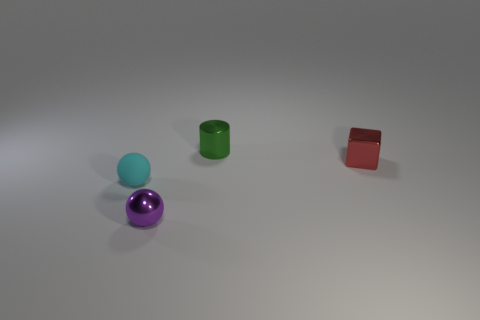How many cylinders are purple objects or cyan things?
Make the answer very short. 0. Is the shape of the tiny rubber thing the same as the tiny green metal object?
Provide a short and direct response. No. There is a object that is behind the tiny red metal object; what size is it?
Your response must be concise. Small. Are there any metal objects of the same color as the small matte ball?
Keep it short and to the point. No. There is a sphere that is to the right of the cyan rubber thing; does it have the same size as the small metal cylinder?
Your answer should be compact. Yes. The small cube is what color?
Your answer should be compact. Red. There is a small thing that is right of the object behind the shiny cube; what is its color?
Your response must be concise. Red. Is there a cylinder made of the same material as the tiny green thing?
Your answer should be very brief. No. What material is the thing to the right of the metallic thing behind the tiny red metallic object made of?
Give a very brief answer. Metal. How many purple things have the same shape as the small green metallic object?
Your answer should be compact. 0. 